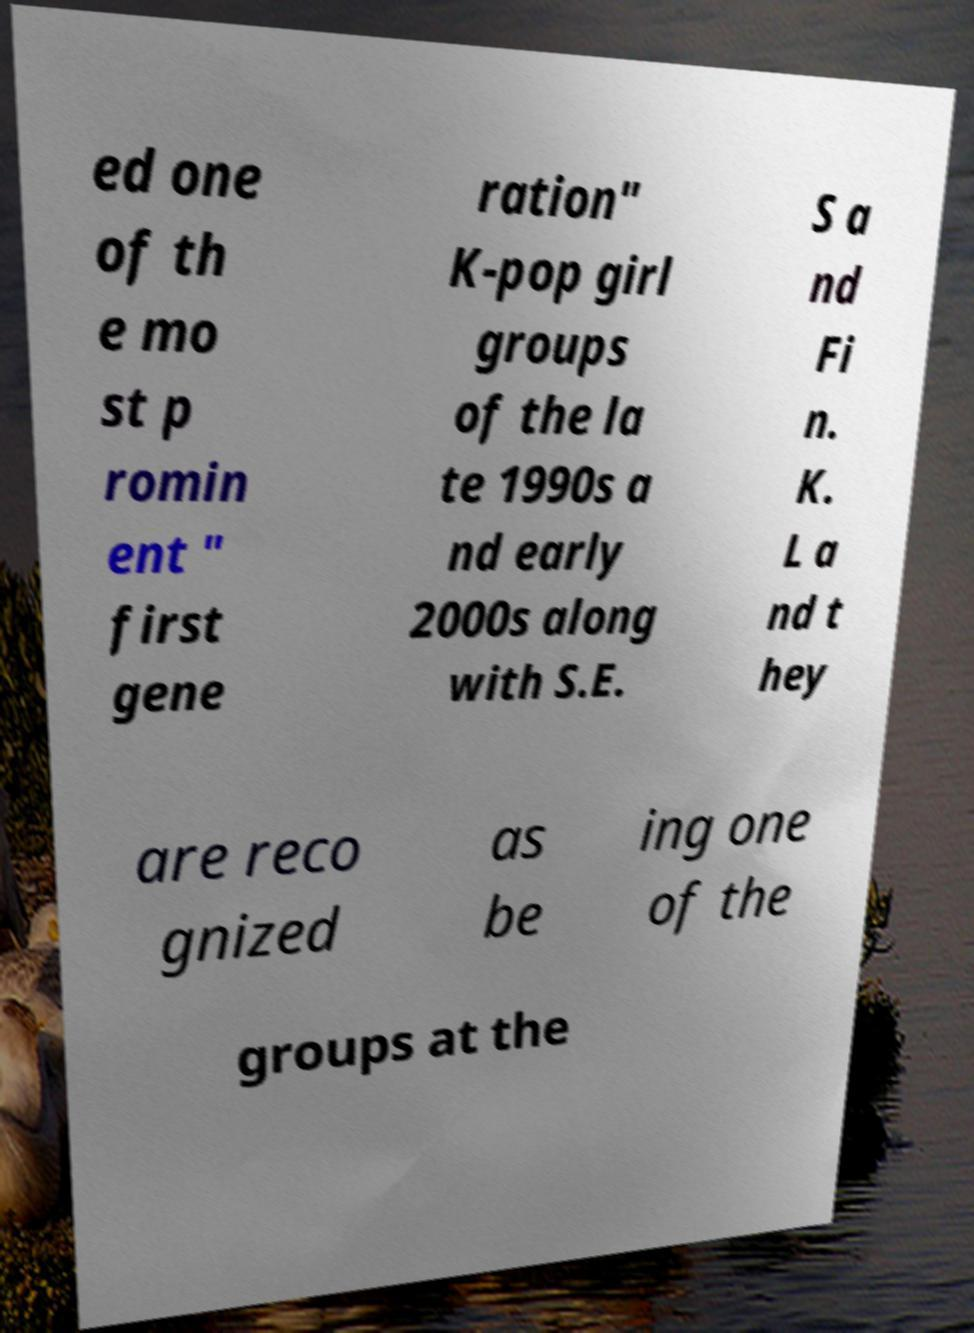I need the written content from this picture converted into text. Can you do that? ed one of th e mo st p romin ent " first gene ration" K-pop girl groups of the la te 1990s a nd early 2000s along with S.E. S a nd Fi n. K. L a nd t hey are reco gnized as be ing one of the groups at the 